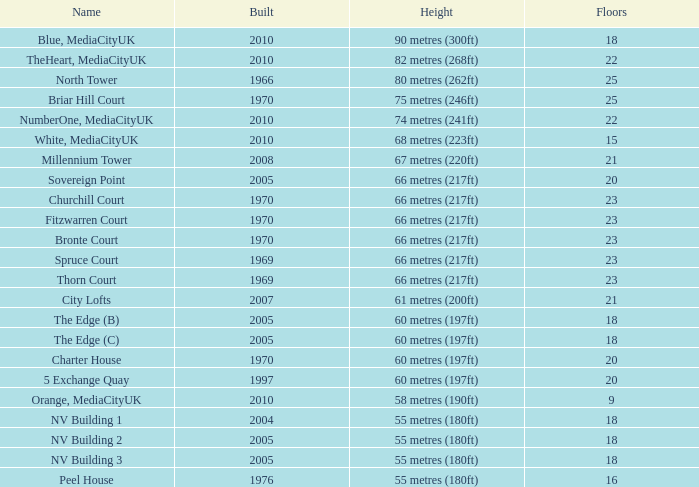What is the overall number of white mediacityuk buildings that have less than 22 floors and a rank under 8? 1.0. 